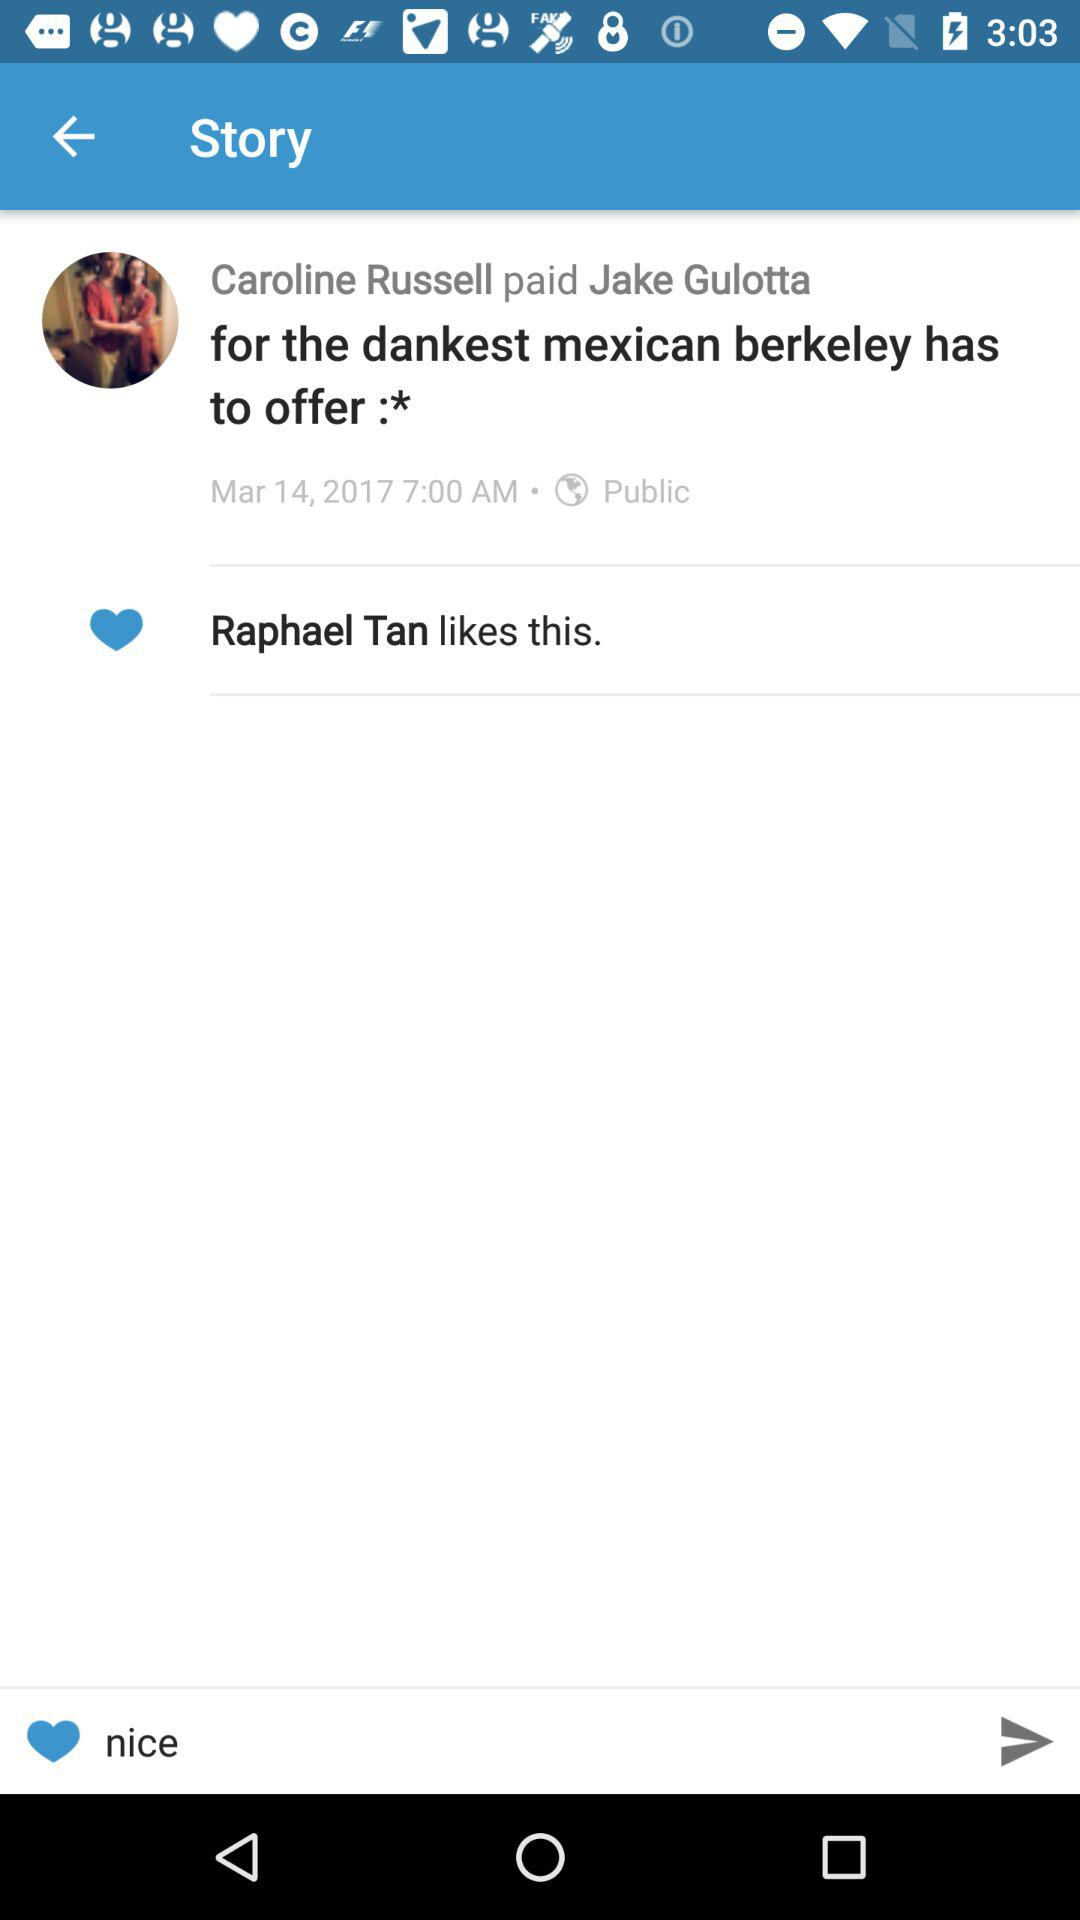How long ago was this payment made?
Answer the question using a single word or phrase. Mar 14, 2017 7:00 AM 